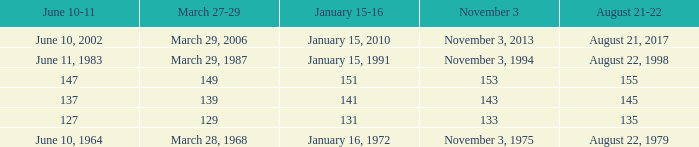 november 3 where march 27-29 is 149? 153.0. 